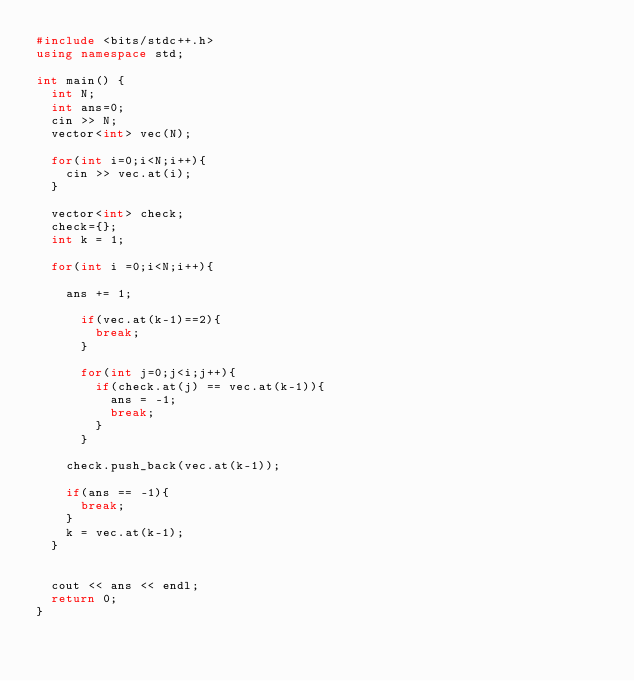<code> <loc_0><loc_0><loc_500><loc_500><_C++_>#include <bits/stdc++.h>
using namespace std;
 
int main() {
  int N;
  int ans=0;
  cin >> N;
  vector<int> vec(N);
  
  for(int i=0;i<N;i++){
    cin >> vec.at(i);   
  }
 
  vector<int> check;
  check={};
  int k = 1;
  
  for(int i =0;i<N;i++){
    
    ans += 1;
    
      if(vec.at(k-1)==2){
        break;
      }
      
      for(int j=0;j<i;j++){
      	if(check.at(j) == vec.at(k-1)){
          ans = -1;
          break;
        }
      }
    
    check.push_back(vec.at(k-1));
    
    if(ans == -1){
      break;
    }
    k = vec.at(k-1);
  }
  
  
  cout << ans << endl;
  return 0;
}</code> 